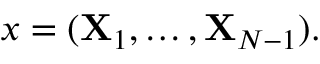<formula> <loc_0><loc_0><loc_500><loc_500>x = ( { X } _ { 1 } , \dots , { X } _ { N - 1 } ) .</formula> 